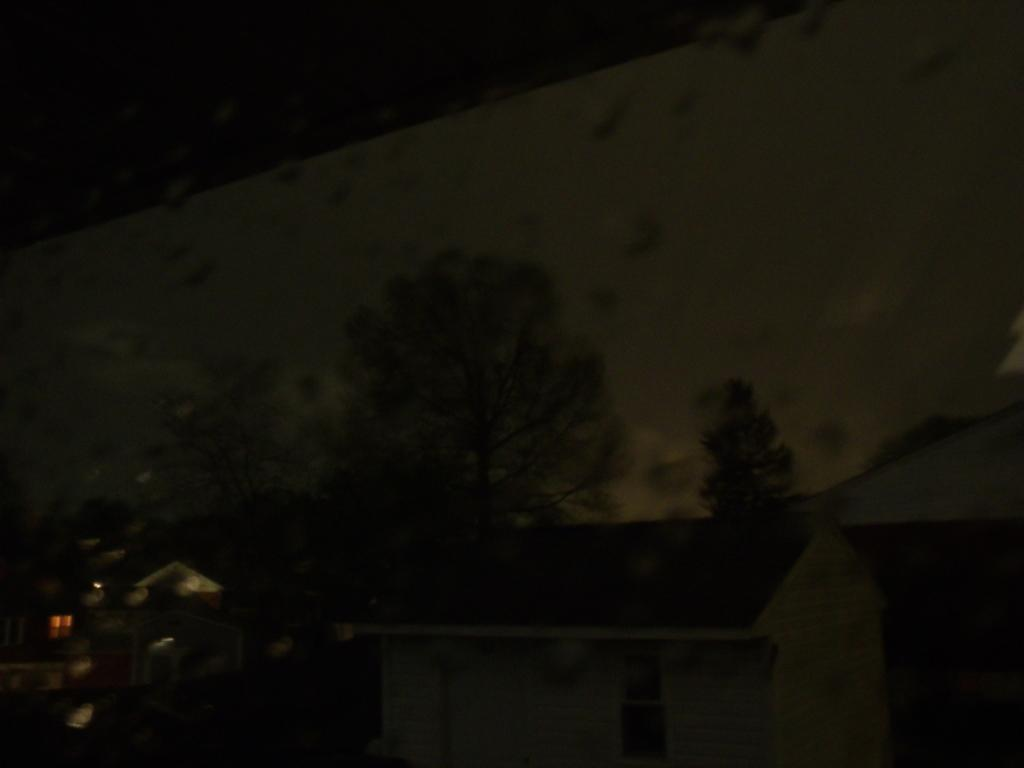What material is present in the image? There is glass in the image. What is on the surface of the glass? Water droplets are present on the glass. What can be seen through the glass? Houses, trees, and the sky are visible through the glass. What type of disgust can be seen on the ground in the image? There is no mention of disgust or a ground in the image; it features glass with water droplets and a view of houses, trees, and the sky. 